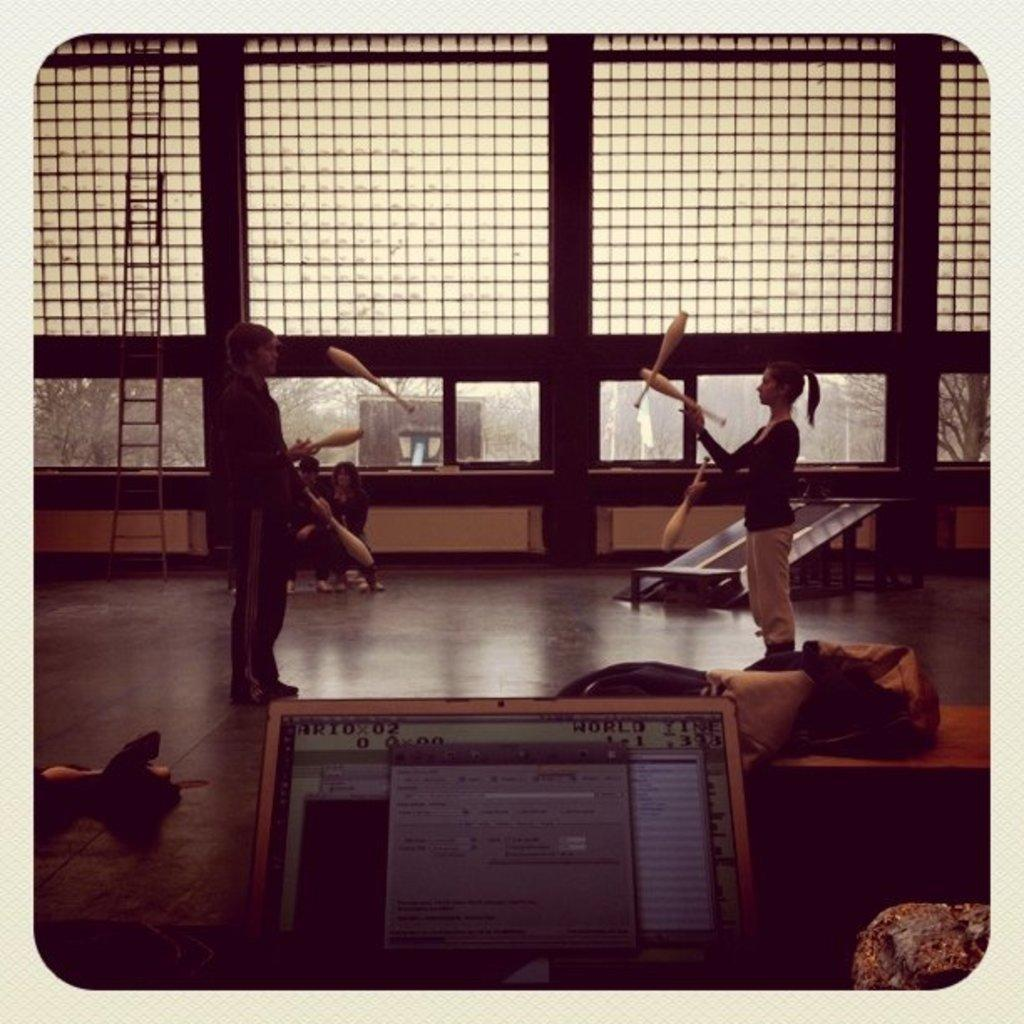What are the people in the image doing? The people in the image are standing on the floor and playing with objects. Can you describe the objects they are playing with? Unfortunately, the specific objects cannot be identified from the provided facts. Are there any other objects or things visible in the image besides the people and the objects they are playing with? Yes, there are other objects or things around in the image. Can you see any smoke coming from the objects the people are playing with in the image? There is no mention of smoke in the provided facts, and therefore it cannot be determined if any smoke is present in the image. 